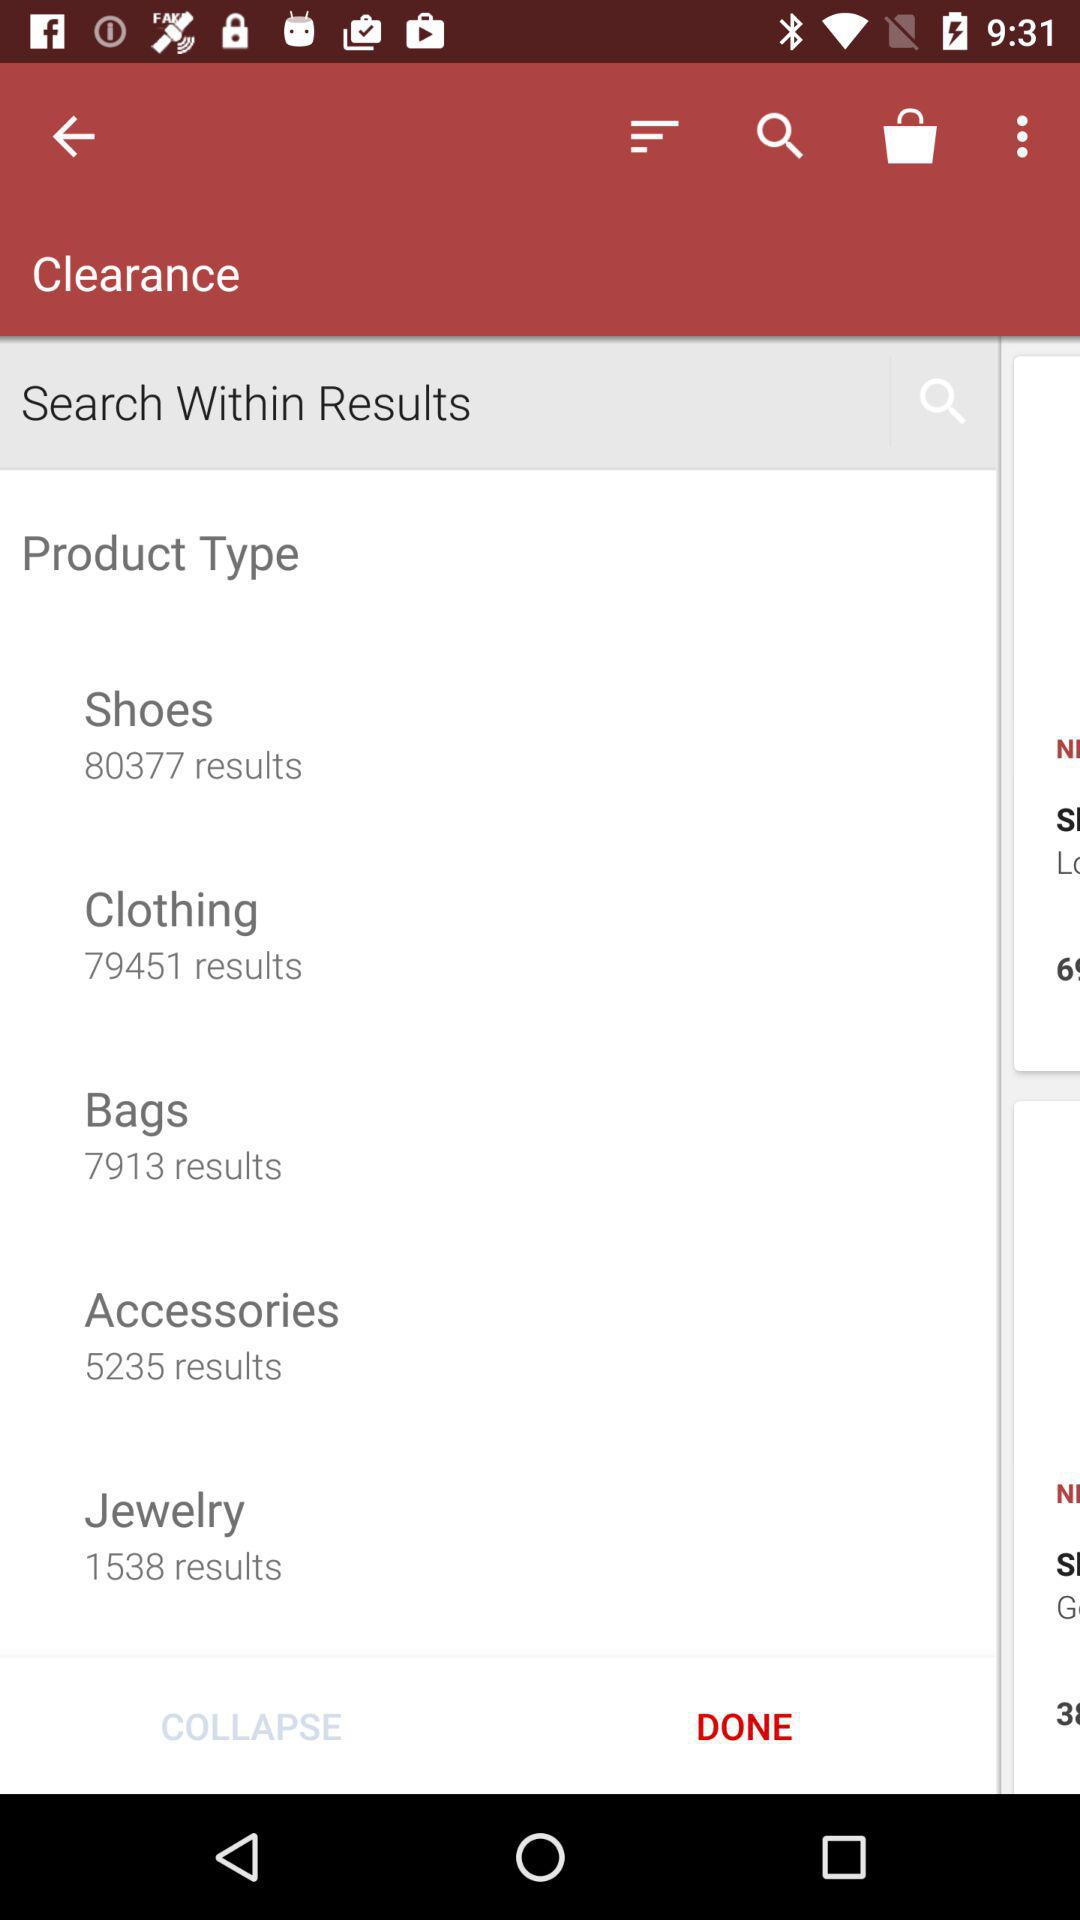How many results are there for Clothing?
Answer the question using a single word or phrase. 79451 